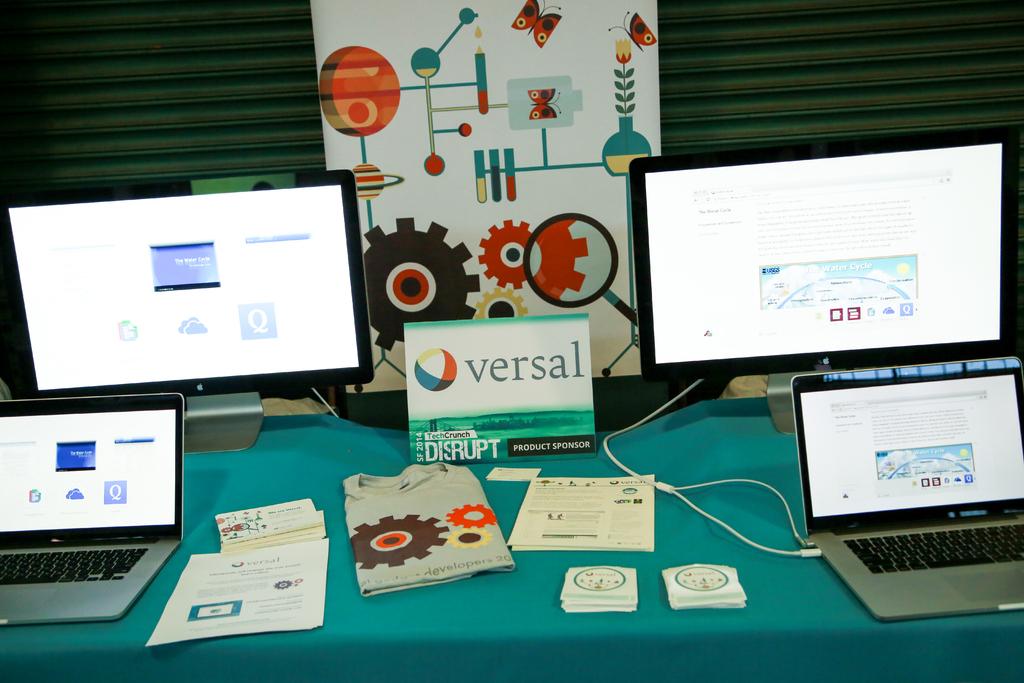What does the sign in the middle say?
Provide a short and direct response. Versal. What word is visible on the shirt?
Offer a terse response. Developers. 